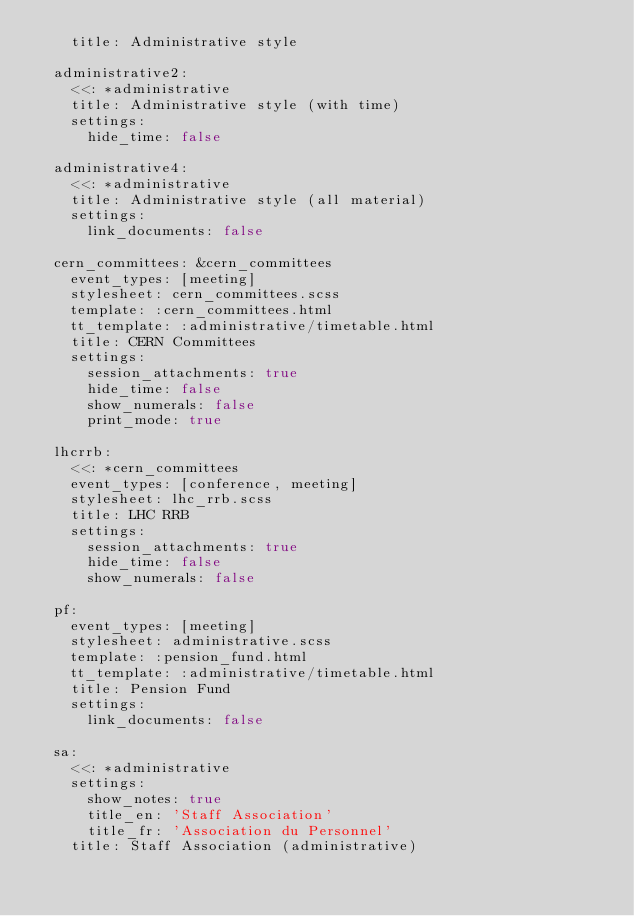<code> <loc_0><loc_0><loc_500><loc_500><_YAML_>    title: Administrative style

  administrative2:
    <<: *administrative
    title: Administrative style (with time)
    settings:
      hide_time: false

  administrative4:
    <<: *administrative
    title: Administrative style (all material)
    settings:
      link_documents: false

  cern_committees: &cern_committees
    event_types: [meeting]
    stylesheet: cern_committees.scss
    template: :cern_committees.html
    tt_template: :administrative/timetable.html
    title: CERN Committees
    settings:
      session_attachments: true
      hide_time: false
      show_numerals: false
      print_mode: true

  lhcrrb:
    <<: *cern_committees
    event_types: [conference, meeting]
    stylesheet: lhc_rrb.scss
    title: LHC RRB
    settings:
      session_attachments: true
      hide_time: false
      show_numerals: false

  pf:
    event_types: [meeting]
    stylesheet: administrative.scss
    template: :pension_fund.html
    tt_template: :administrative/timetable.html
    title: Pension Fund
    settings:
      link_documents: false

  sa:
    <<: *administrative
    settings:
      show_notes: true
      title_en: 'Staff Association'
      title_fr: 'Association du Personnel'
    title: Staff Association (administrative)
</code> 